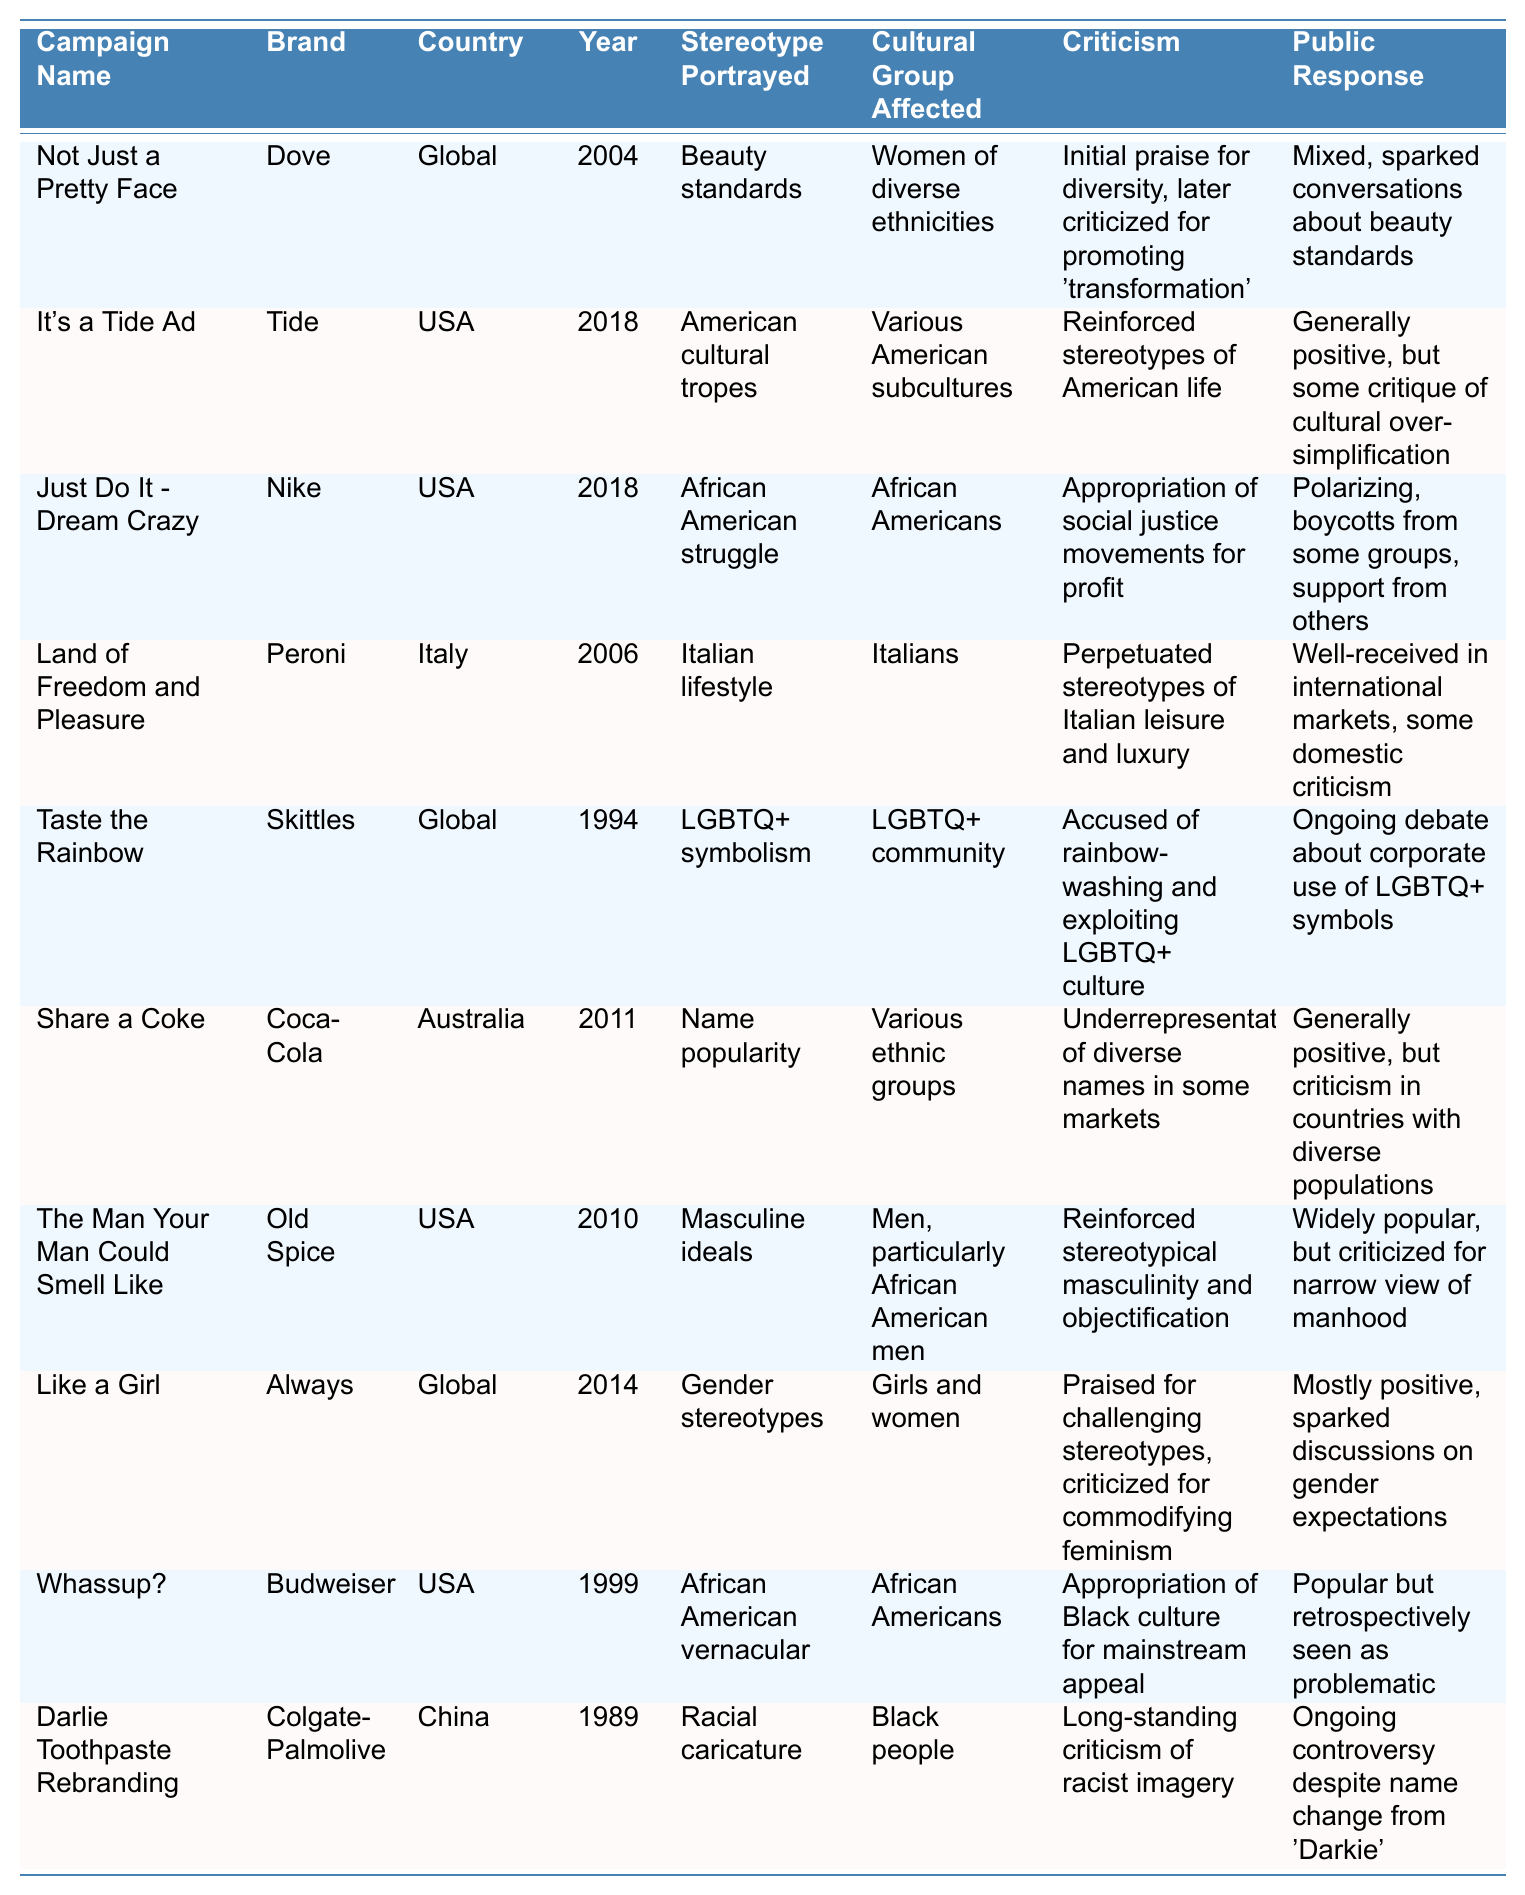What campaign features the brand Dove? According to the table, the campaign named "Not Just a Pretty Face" features the brand Dove.
Answer: Not Just a Pretty Face Which cultural group is affected by the "Taste the Rainbow" campaign? The table indicates that the "Taste the Rainbow" campaign affects the LGBTQ+ community.
Answer: LGBTQ+ community How many campaigns portray stereotypes related to American culture? There are two campaigns in the table that portray stereotypes related to American culture: "It's a Tide Ad" and "Just Do It - Dream Crazy."
Answer: 2 What was the public response to the "Like a Girl" campaign? The table states that the public response to the "Like a Girl" campaign was mostly positive and sparked discussions on gender expectations.
Answer: Mostly positive Which campaign faced criticism for promoting racial caricatures? The "Darlie Toothpaste Rebranding" campaign faced criticism for promoting racial caricature, as indicated in the table.
Answer: Darlie Toothpaste Rebranding How many campaigns were released in the USA? Upon reviewing the table, four campaigns were released in the USA: "It's a Tide Ad," "Just Do It - Dream Crazy," "The Man Your Man Could Smell Like," and "Whassup?"
Answer: 4 Was the "Land of Freedom and Pleasure" campaign well-received? Yes, the table notes that the "Land of Freedom and Pleasure" campaign was well-received in international markets, although it faced some domestic criticism.
Answer: Yes Did any campaign receive mixed reactions? Yes, the "Not Just a Pretty Face" campaign received mixed reactions, as it initially sparked praise for diversity but later faced criticism for promoting 'transformation.'
Answer: Yes Which two campaigns were criticized for appropriating elements of culture? The "Just Do It - Dream Crazy" campaign and the "Whassup?" campaign were both critiqued for appropriating elements of culture, according to the table.
Answer: Just Do It - Dream Crazy and Whassup? What stereotype is portrayed in the "Share a Coke" campaign, and what was the public response? The stereotype portrayed in the "Share a Coke" campaign relates to name popularity among various ethnic groups, which received a generally positive response but criticism in diverse populations.
Answer: Name popularity; Generally positive with criticism in diverse populations How would you categorize the overall depiction of gender in the campaigns provided? The table shows that campaigns like "Like a Girl" and "The Man Your Man Could Smell Like" depict gender stereotypes, with mixed responses to how these issues are portrayed.
Answer: Mixed depiction of gender stereotypes 